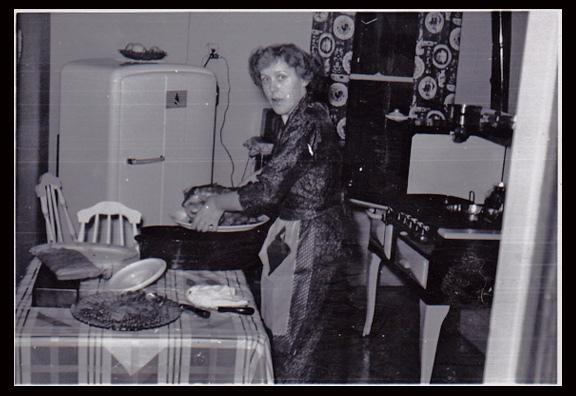What type of region is this likely?

Choices:
A) farm
B) coastal
C) deserted
D) city city 